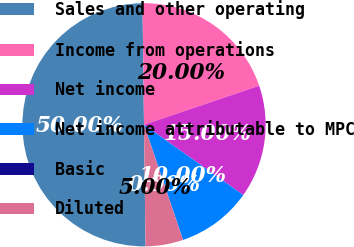Convert chart. <chart><loc_0><loc_0><loc_500><loc_500><pie_chart><fcel>Sales and other operating<fcel>Income from operations<fcel>Net income<fcel>Net income attributable to MPC<fcel>Basic<fcel>Diluted<nl><fcel>50.0%<fcel>20.0%<fcel>15.0%<fcel>10.0%<fcel>0.0%<fcel>5.0%<nl></chart> 